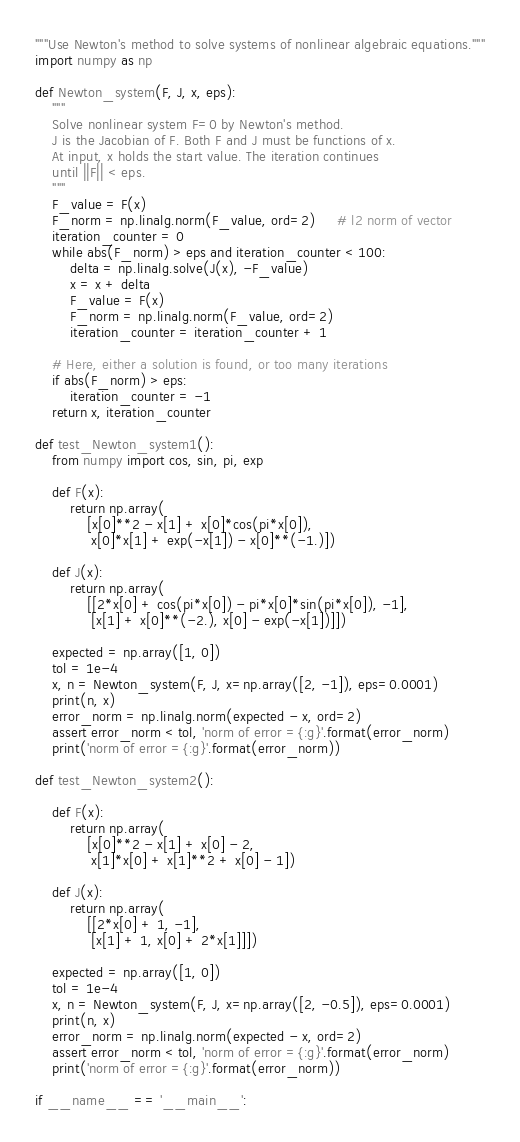<code> <loc_0><loc_0><loc_500><loc_500><_Python_>"""Use Newton's method to solve systems of nonlinear algebraic equations."""
import numpy as np

def Newton_system(F, J, x, eps):
    """
    Solve nonlinear system F=0 by Newton's method.
    J is the Jacobian of F. Both F and J must be functions of x.
    At input, x holds the start value. The iteration continues
    until ||F|| < eps.
    """
    F_value = F(x)
    F_norm = np.linalg.norm(F_value, ord=2)     # l2 norm of vector
    iteration_counter = 0
    while abs(F_norm) > eps and iteration_counter < 100:
        delta = np.linalg.solve(J(x), -F_value)
        x = x + delta
        F_value = F(x)
        F_norm = np.linalg.norm(F_value, ord=2)
        iteration_counter = iteration_counter + 1

    # Here, either a solution is found, or too many iterations
    if abs(F_norm) > eps:
        iteration_counter = -1
    return x, iteration_counter

def test_Newton_system1():
    from numpy import cos, sin, pi, exp

    def F(x):
        return np.array(
            [x[0]**2 - x[1] + x[0]*cos(pi*x[0]),
             x[0]*x[1] + exp(-x[1]) - x[0]**(-1.)])

    def J(x):
        return np.array(
            [[2*x[0] + cos(pi*x[0]) - pi*x[0]*sin(pi*x[0]), -1],
             [x[1] + x[0]**(-2.), x[0] - exp(-x[1])]])

    expected = np.array([1, 0])
    tol = 1e-4
    x, n = Newton_system(F, J, x=np.array([2, -1]), eps=0.0001)
    print(n, x)
    error_norm = np.linalg.norm(expected - x, ord=2)
    assert error_norm < tol, 'norm of error ={:g}'.format(error_norm)
    print('norm of error ={:g}'.format(error_norm))

def test_Newton_system2():

    def F(x):
        return np.array(
            [x[0]**2 - x[1] + x[0] - 2,
             x[1]*x[0] + x[1]**2 + x[0] - 1])

    def J(x):
        return np.array(
            [[2*x[0] + 1, -1],
             [x[1] + 1, x[0] + 2*x[1]]])

    expected = np.array([1, 0])
    tol = 1e-4
    x, n = Newton_system(F, J, x=np.array([2, -0.5]), eps=0.0001)
    print(n, x)
    error_norm = np.linalg.norm(expected - x, ord=2)
    assert error_norm < tol, 'norm of error ={:g}'.format(error_norm)
    print('norm of error ={:g}'.format(error_norm))

if __name__ == '__main__':</code> 